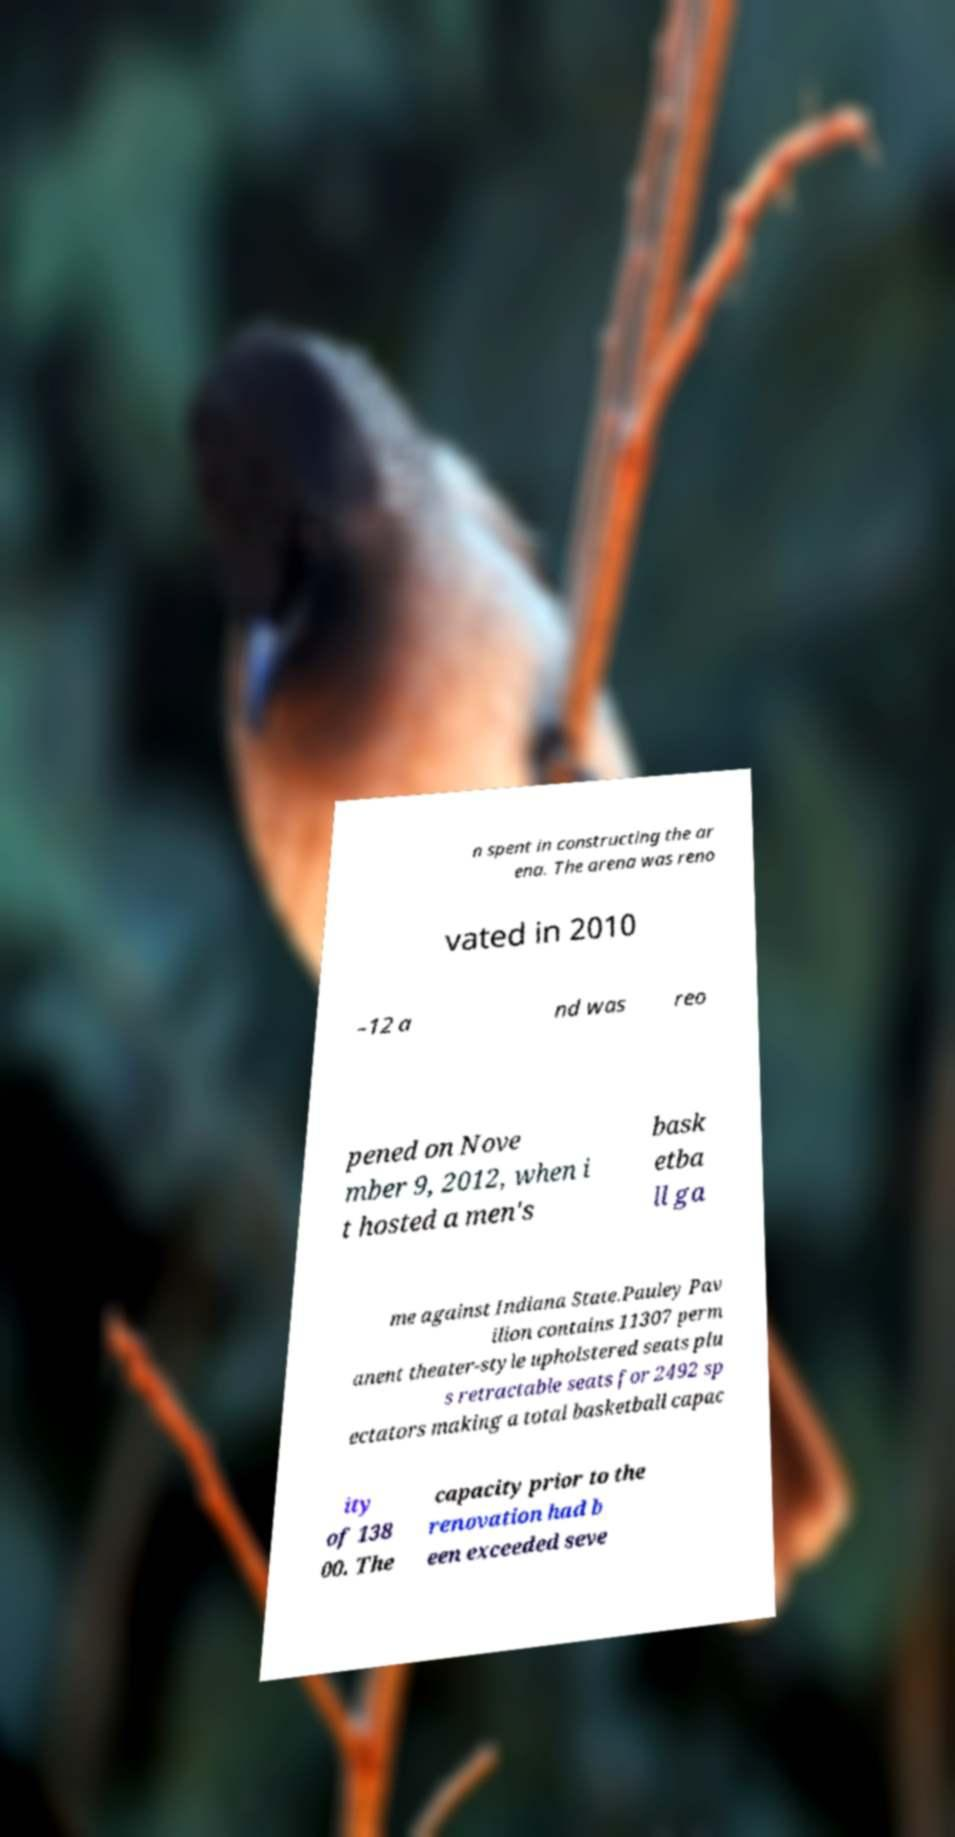Could you extract and type out the text from this image? n spent in constructing the ar ena. The arena was reno vated in 2010 –12 a nd was reo pened on Nove mber 9, 2012, when i t hosted a men's bask etba ll ga me against Indiana State.Pauley Pav ilion contains 11307 perm anent theater-style upholstered seats plu s retractable seats for 2492 sp ectators making a total basketball capac ity of 138 00. The capacity prior to the renovation had b een exceeded seve 